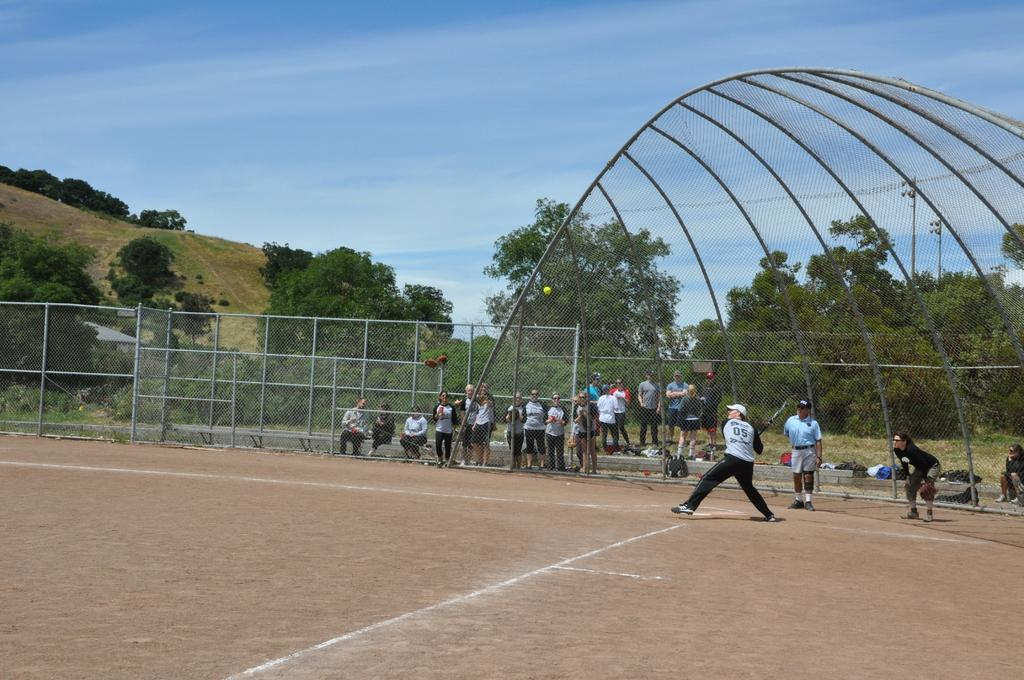Provide a one-sentence caption for the provided image. The batter on the field has the number 05 written on his shirt. 